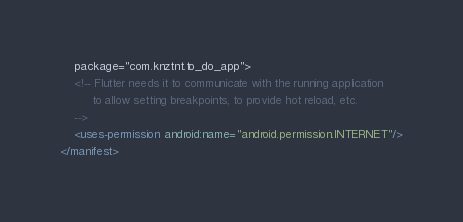Convert code to text. <code><loc_0><loc_0><loc_500><loc_500><_XML_>    package="com.knztnt.to_do_app">
    <!-- Flutter needs it to communicate with the running application
         to allow setting breakpoints, to provide hot reload, etc.
    -->
    <uses-permission android:name="android.permission.INTERNET"/>
</manifest>
</code> 